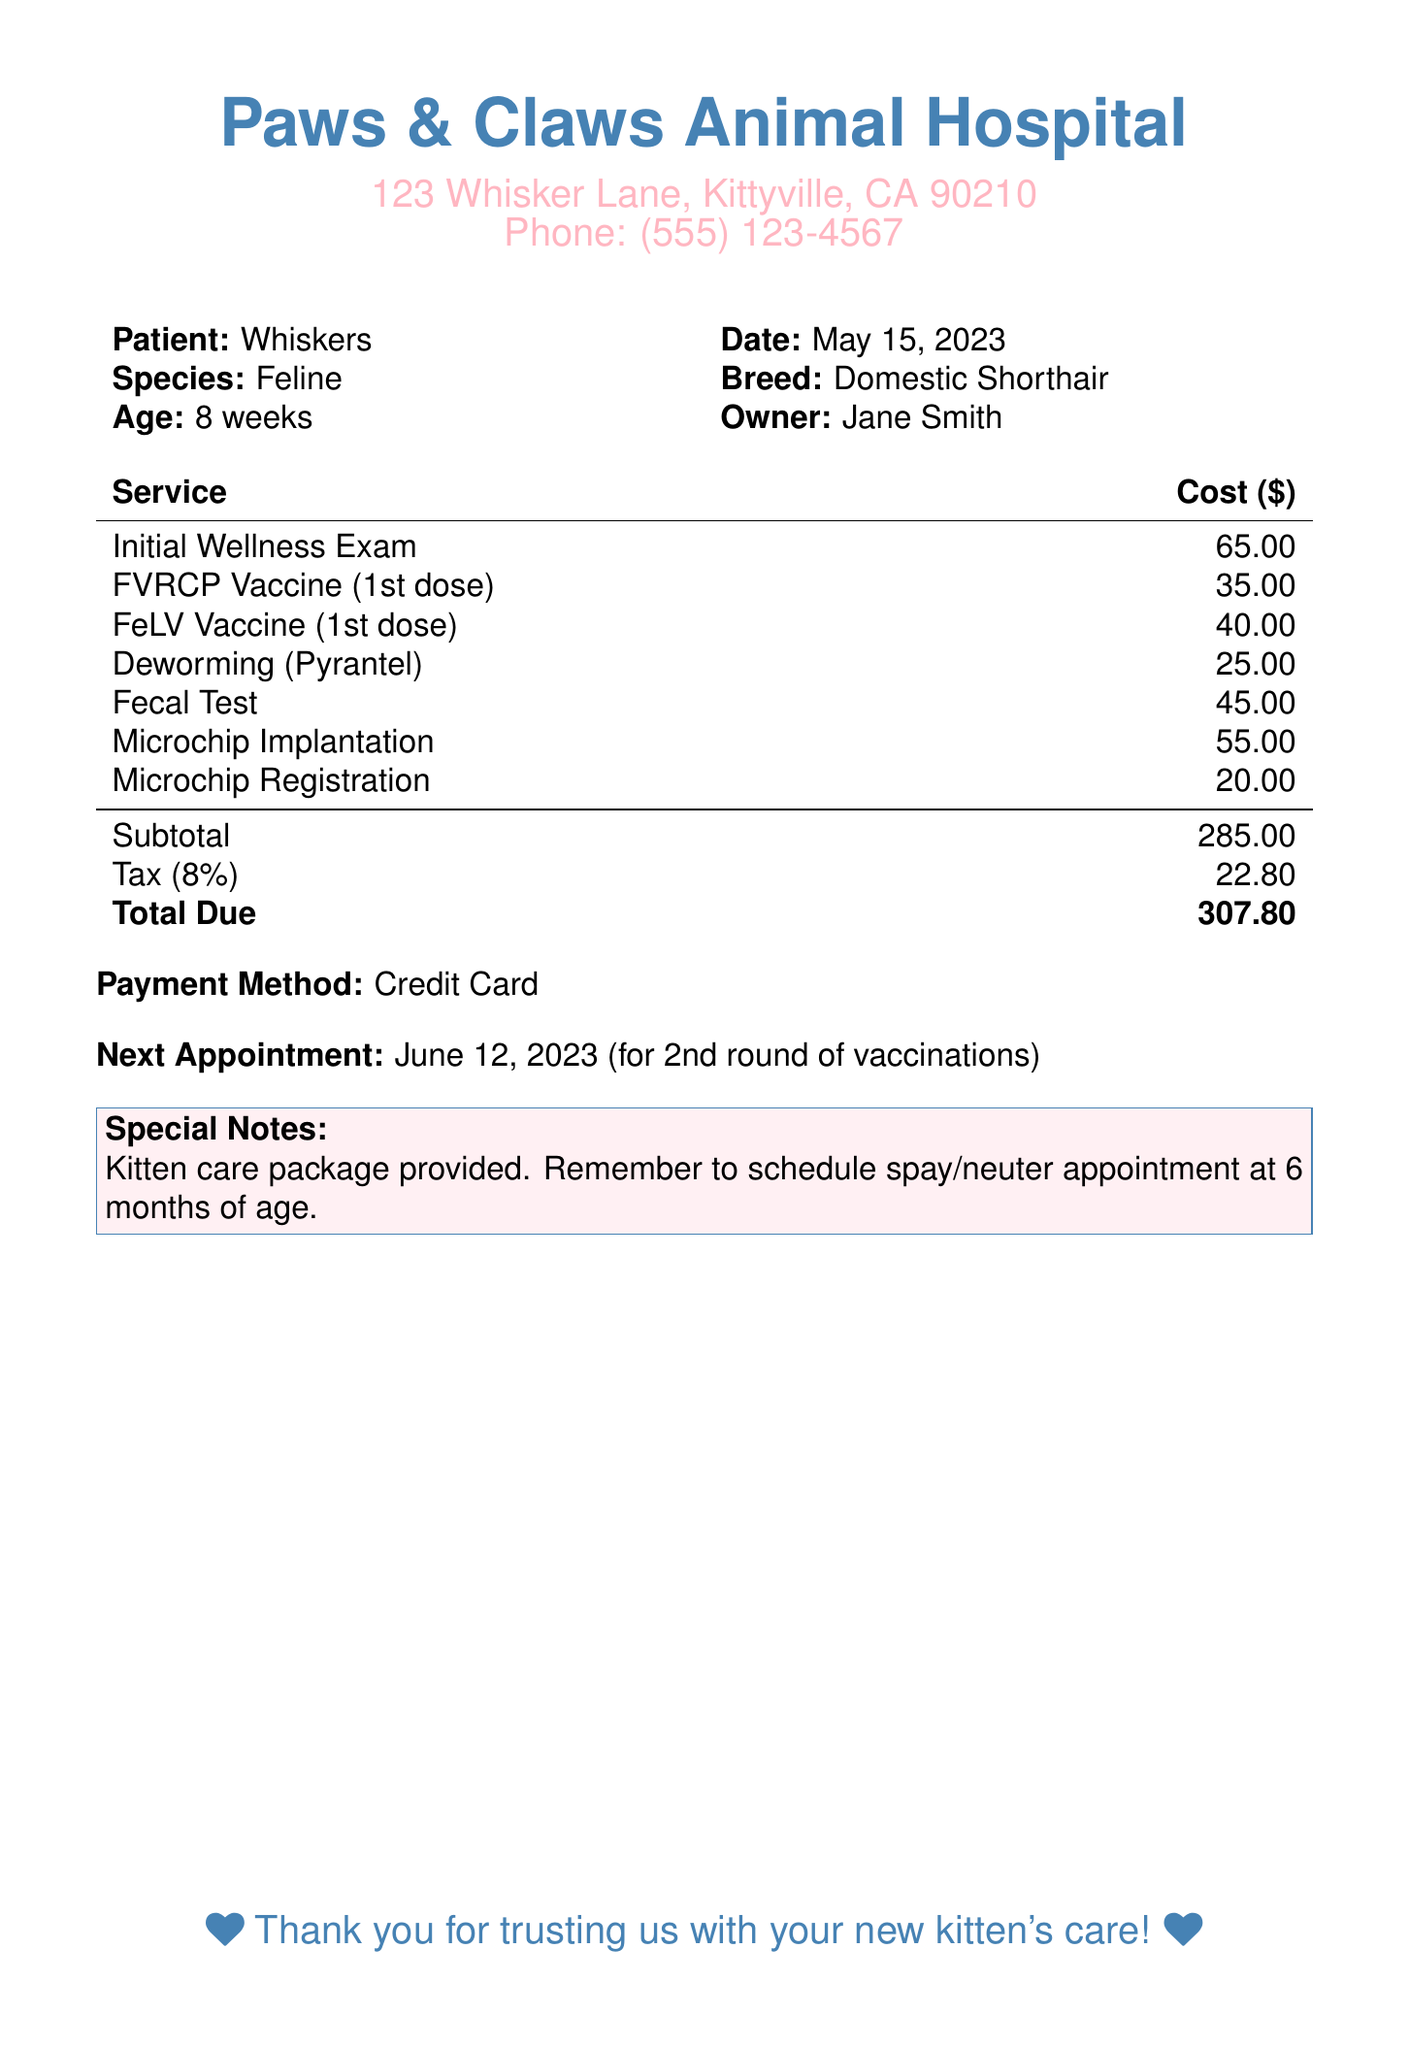What is the total due? The total due is the final amount calculated from the subtotal and tax in the bill.
Answer: 307.80 What is the cost of the FVRCP vaccine? The FVRCP vaccine is listed as one of the services with its corresponding cost in the document.
Answer: 35.00 What is the patient's age? The age of the patient is mentioned in the section that provides patient details.
Answer: 8 weeks What date is the next appointment scheduled for? The date for the next appointment is specified in the document under the payment method section.
Answer: June 12, 2023 What are the two vaccines administered? The document lists specific vaccinations given during the kitten's initial visit, requiring identification of two from the list.
Answer: FVRCP Vaccine (1st dose), FeLV Vaccine (1st dose) What is included in the special notes? The special notes section includes reminders and additional information relevant to the pet owner's responsibilities.
Answer: Kitten care package provided. Remember to schedule spay/neuter appointment at 6 months of age What is the tax rate applied to the subtotal? The tax is calculated as a percentage of the subtotal, which is explicitly mentioned in the breakdown.
Answer: 8% What method was used for payment? The payment method is indicated in a specific section of the document regarding the financial transaction.
Answer: Credit Card 